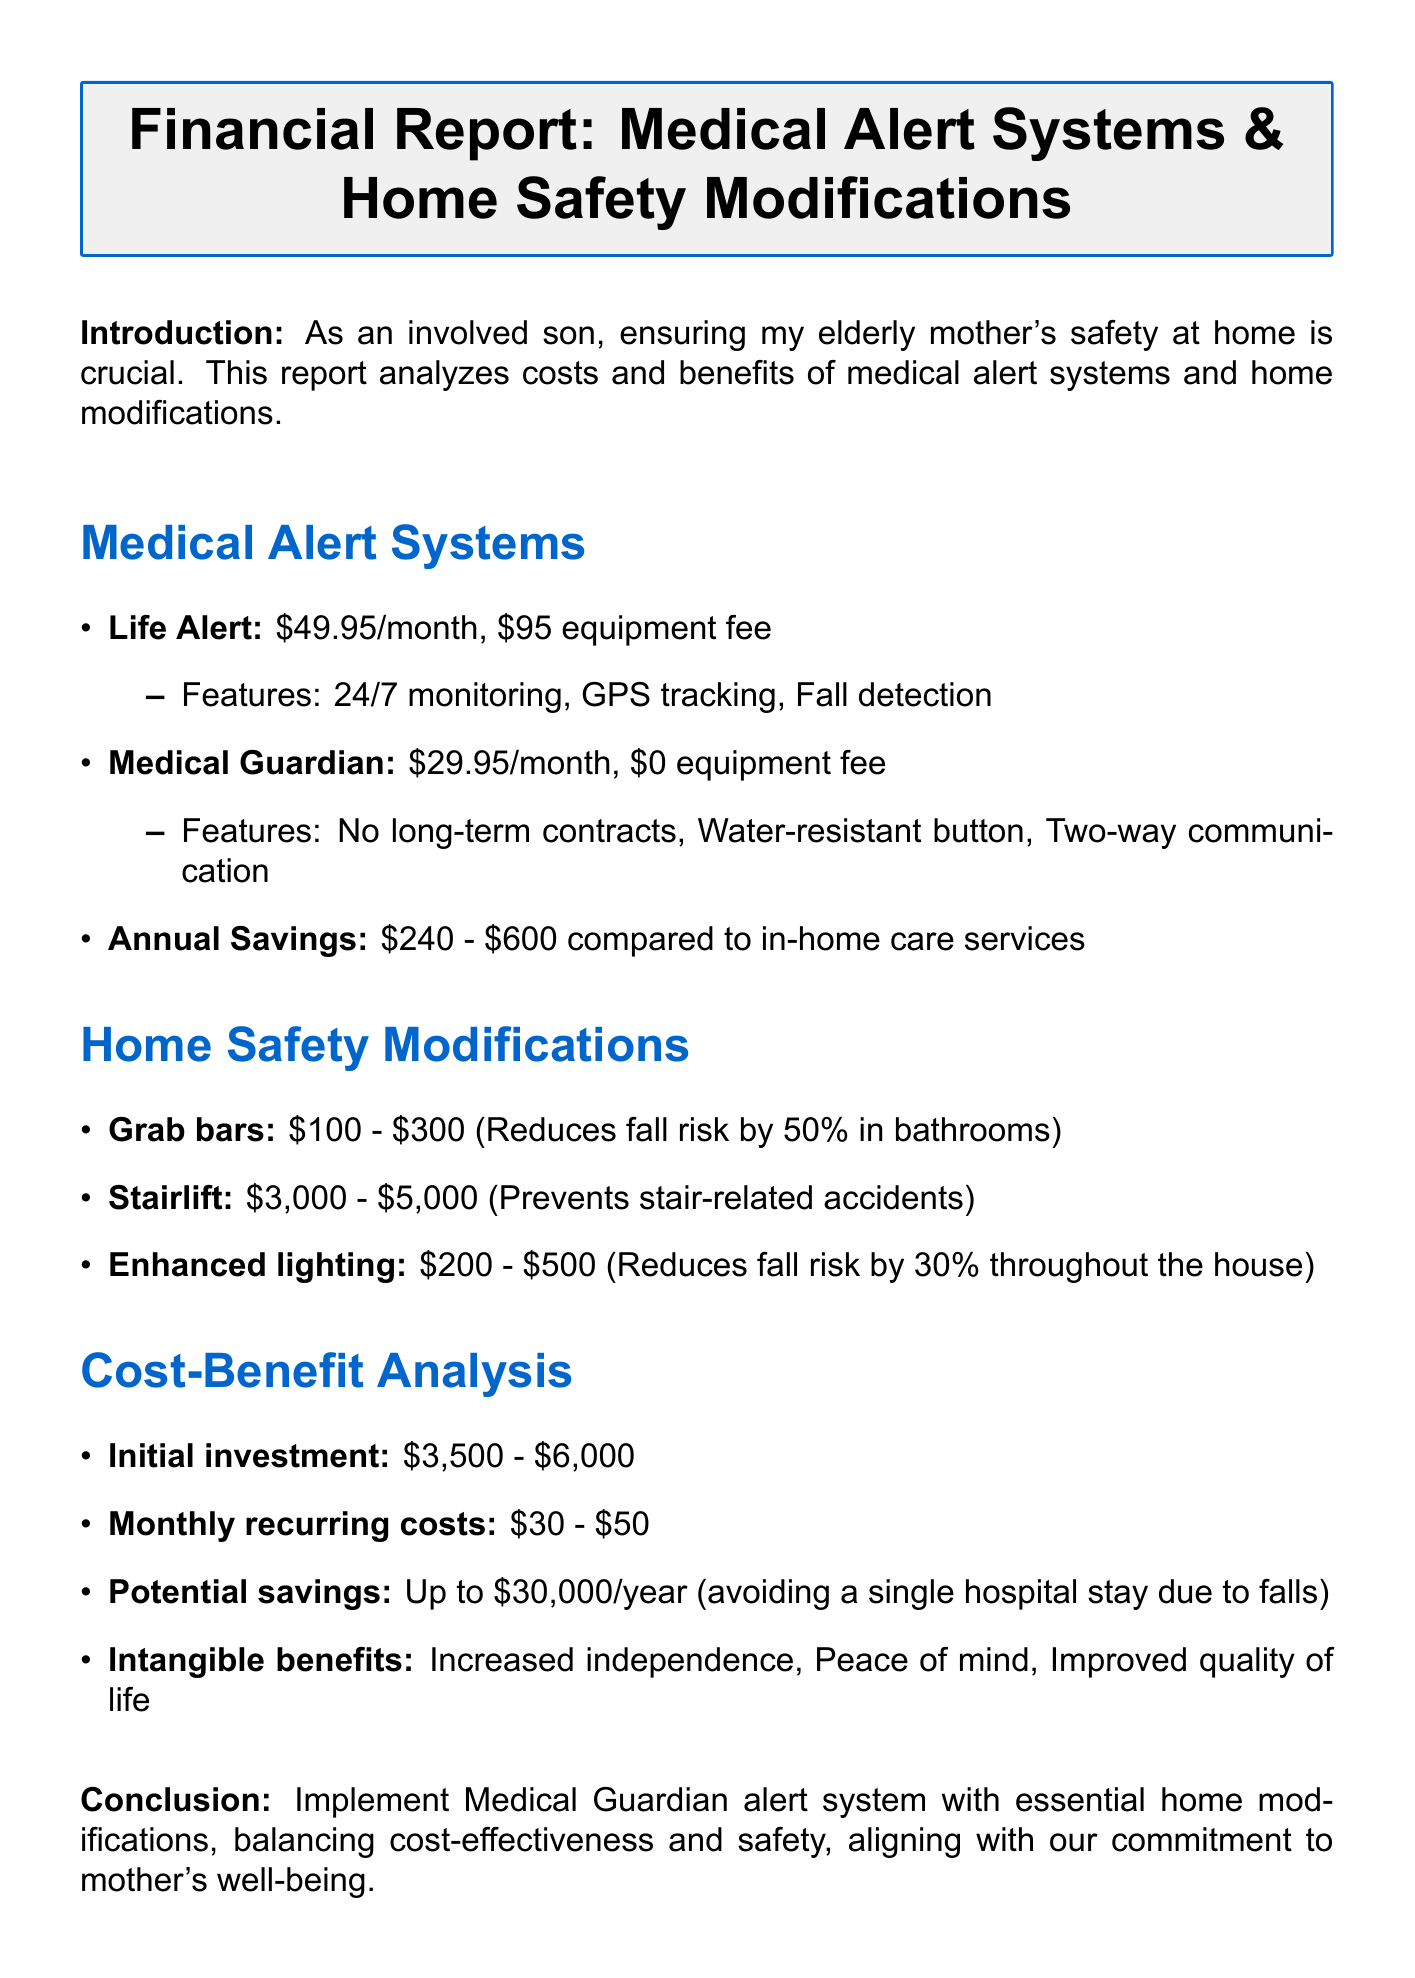What is the monthly cost of Life Alert? The monthly cost for Life Alert is explicitly stated in the document.
Answer: $49.95 What features does Medical Guardian offer? The document lists the features of Medical Guardian under its description.
Answer: No long-term contracts, Water-resistant button, Two-way communication What is the estimated annual savings compared to in-home care services? The document provides a range for potential annual savings.
Answer: $240 - $600 What is the lowest cost for the installation of grab bars? The document specifies the cost range for grab bars installation.
Answer: $100 What is the potential savings by avoiding a single hospital stay due to falls? The document outlines the potential savings related to hospital stays.
Answer: Up to $30,000 per year Which safety modification reduces fall risk by 30%? The document indicates which modification specifically reduces fall risk by 30%.
Answer: Enhanced lighting What is the recommended combination for safety measures? The conclusion section provides a specific recommendation for safety measures.
Answer: Medical Guardian alert system and essential home modifications What is the initial investment range mentioned in the cost-benefit analysis? The document lists the range for initial investments required for safety measures.
Answer: $3,500 - $6,000 What advantage does a stairlift provide? The document explains the benefit of installing a stairlift.
Answer: Prevents stair-related accidents, extends independent living 